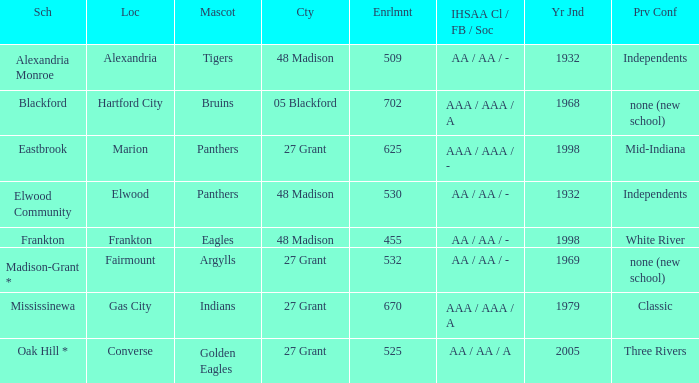What is the previous conference when the location is converse? Three Rivers. 